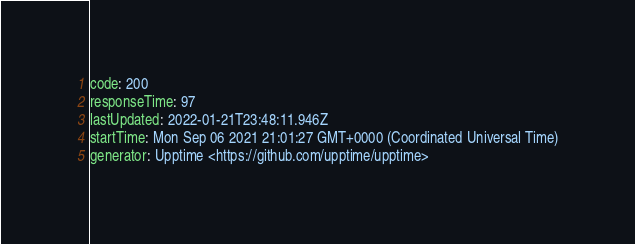<code> <loc_0><loc_0><loc_500><loc_500><_YAML_>code: 200
responseTime: 97
lastUpdated: 2022-01-21T23:48:11.946Z
startTime: Mon Sep 06 2021 21:01:27 GMT+0000 (Coordinated Universal Time)
generator: Upptime <https://github.com/upptime/upptime>
</code> 